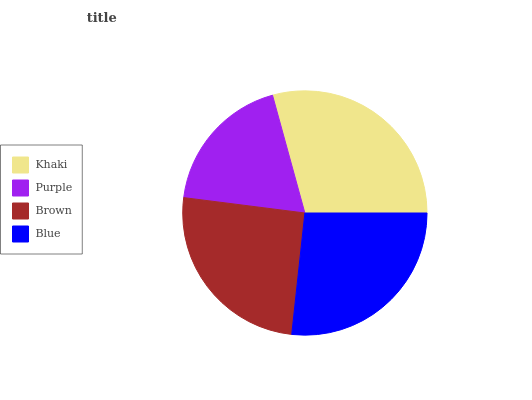Is Purple the minimum?
Answer yes or no. Yes. Is Khaki the maximum?
Answer yes or no. Yes. Is Brown the minimum?
Answer yes or no. No. Is Brown the maximum?
Answer yes or no. No. Is Brown greater than Purple?
Answer yes or no. Yes. Is Purple less than Brown?
Answer yes or no. Yes. Is Purple greater than Brown?
Answer yes or no. No. Is Brown less than Purple?
Answer yes or no. No. Is Blue the high median?
Answer yes or no. Yes. Is Brown the low median?
Answer yes or no. Yes. Is Khaki the high median?
Answer yes or no. No. Is Purple the low median?
Answer yes or no. No. 